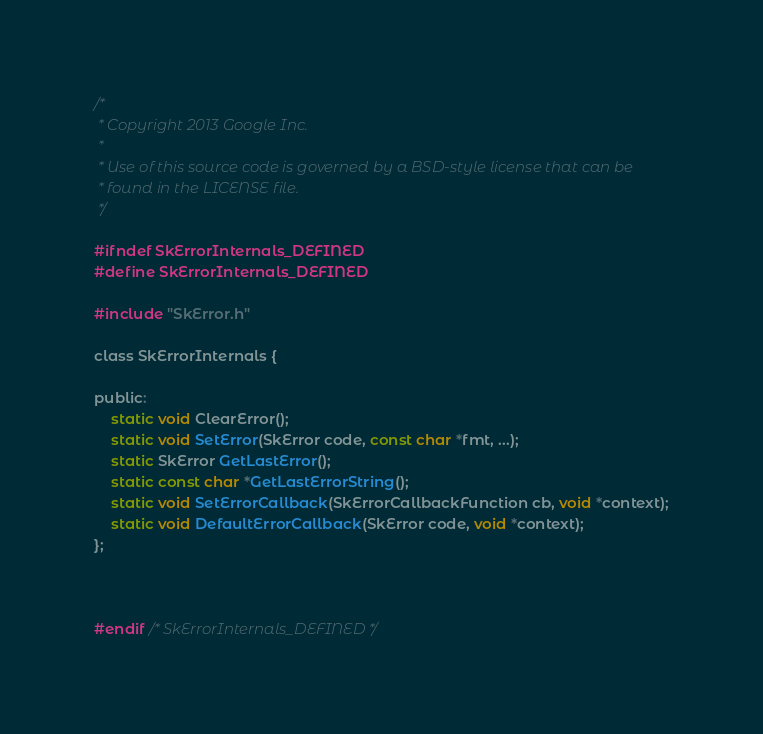<code> <loc_0><loc_0><loc_500><loc_500><_C_>/*
 * Copyright 2013 Google Inc.
 *
 * Use of this source code is governed by a BSD-style license that can be
 * found in the LICENSE file.
 */

#ifndef SkErrorInternals_DEFINED
#define SkErrorInternals_DEFINED

#include "SkError.h"

class SkErrorInternals {

public:
    static void ClearError();
    static void SetError(SkError code, const char *fmt, ...);
    static SkError GetLastError();
    static const char *GetLastErrorString();
    static void SetErrorCallback(SkErrorCallbackFunction cb, void *context);
    static void DefaultErrorCallback(SkError code, void *context);
};



#endif /* SkErrorInternals_DEFINED */
</code> 